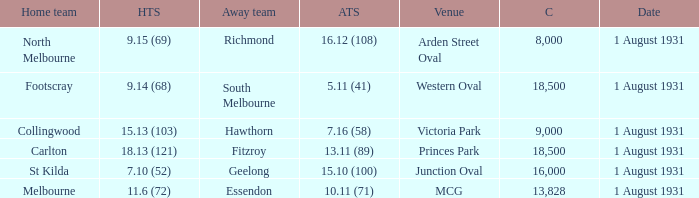What is the home team at the venue mcg? Melbourne. 